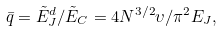<formula> <loc_0><loc_0><loc_500><loc_500>\bar { q } = { \tilde { E } ^ { d } _ { J } } / { \tilde { E } _ { C } } = 4 N ^ { 3 / 2 } \upsilon / \pi ^ { 2 } E _ { J } ,</formula> 